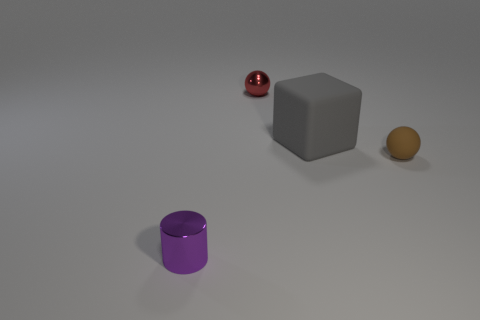Does the tiny red object have the same material as the tiny sphere that is in front of the gray cube?
Provide a short and direct response. No. There is a small metallic object that is in front of the brown ball; what shape is it?
Offer a very short reply. Cylinder. Is the number of tiny brown things the same as the number of tiny spheres?
Offer a terse response. No. What number of other objects are the same material as the large block?
Offer a terse response. 1. What is the size of the metal cylinder?
Offer a very short reply. Small. What number of other things are there of the same color as the matte ball?
Give a very brief answer. 0. What color is the thing that is both right of the red thing and behind the brown matte object?
Your response must be concise. Gray. How many brown objects are there?
Ensure brevity in your answer.  1. Do the red thing and the tiny brown ball have the same material?
Your answer should be compact. No. What is the shape of the metal object that is to the right of the shiny object in front of the metal object that is on the right side of the small cylinder?
Give a very brief answer. Sphere. 